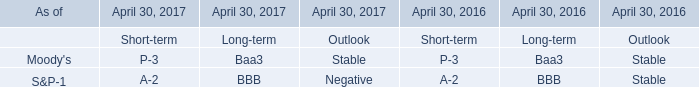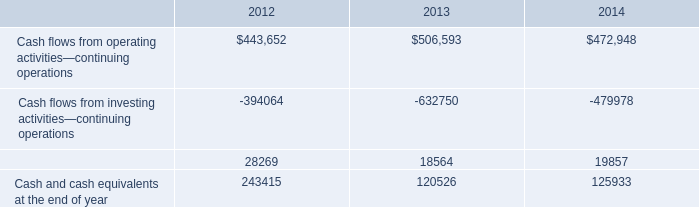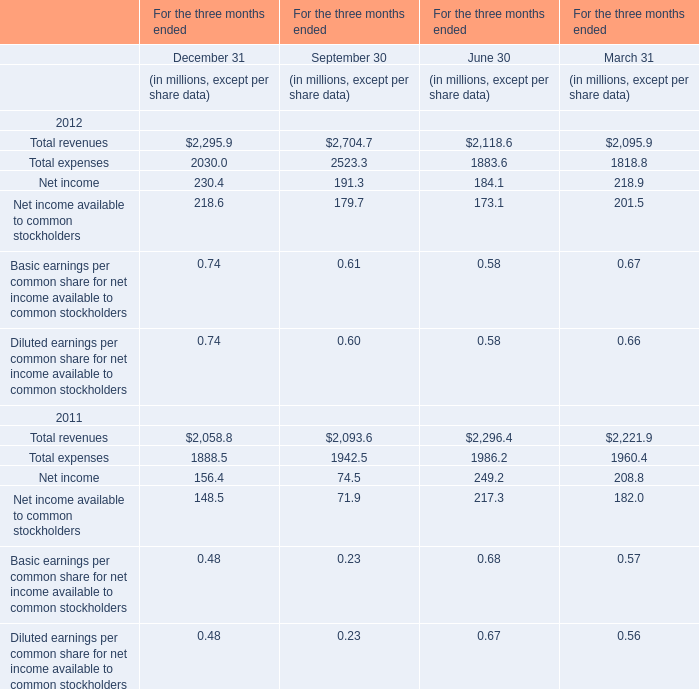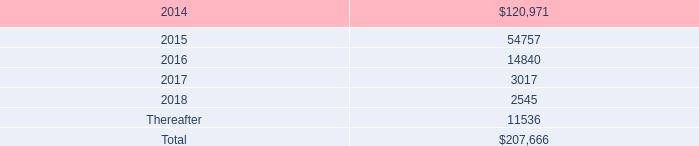at december 31 , 2013 , what was the percent of the environmental-related reserves that was related to asset retirement obligations 
Computations: (26.5 / 34.1)
Answer: 0.77713. 